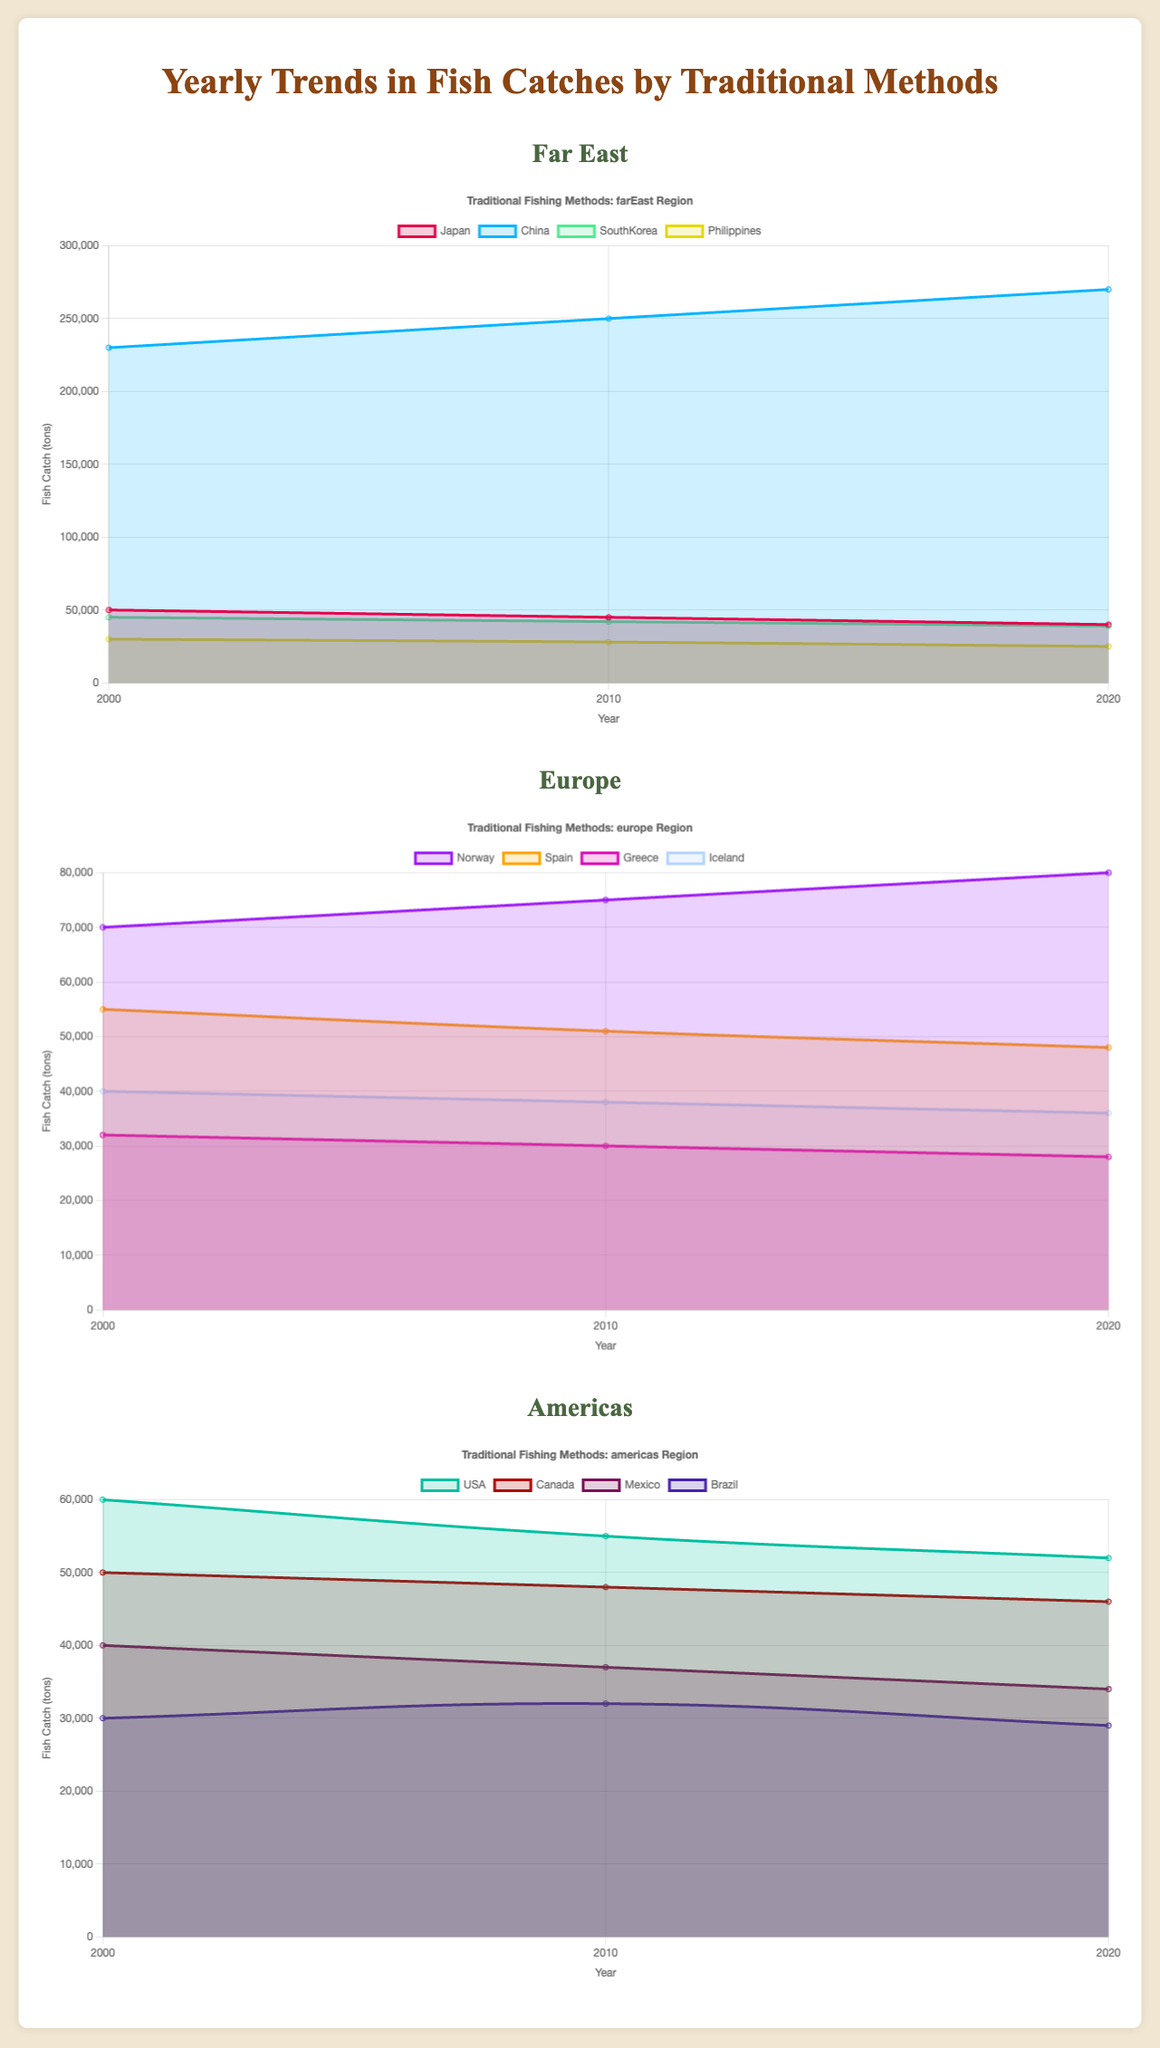What is the trend of fish catches in Japan from 2000 to 2020? Looking at the Far East chart, we see that Japan’s fish catches decrease from 50000 tons in 2000 to 45000 tons in 2010, and further to 40000 tons in 2020.
Answer: Decreasing Which country in the Far East shows the highest fish catch in all years? Referring to the Far East chart, China consistently has the highest fish catches from 2000 to 2020, surpassing other countries like Japan, South Korea, and the Philippines.
Answer: China How much more fish did Norway catch compared to Greece in 2010? In the Europe chart, Norway caught 75000 tons in 2010, while Greece caught 30000 tons. The difference is 75000 - 30000 = 45000 tons.
Answer: 45000 tons What is the average fish catch of Canada in the years 2000, 2010, and 2020? In the Americas chart, Canada’s fish catches are 50000 tons in 2000, 48000 tons in 2010, and 46000 tons in 2020. The average is calculated as (50000 + 48000 + 46000) / 3 = 48000 tons.
Answer: 48000 tons Which European country experienced a decline in fish catches from 2000 to 2020? In the Europe chart, Spain’s fish catches decreased from 55000 tons in 2000 to 51000 tons in 2010, and further to 48000 tons in 2020.
Answer: Spain Between the USA and Mexico, which country had a steeper decline in fish catches from 2000 to 2020? In the Americas chart, the USA’s fish catches decreased from 60000 tons in 2000 to 52000 tons in 2020, a difference of 8000 tons. Mexico’s catches decreased from 40000 tons in 2000 to 34000 tons in 2020, a difference of 6000 tons. Therefore, the USA had a steeper decline.
Answer: USA What is the total fish catch for South Korea over the three recorded years? South Korea’s fish catches in the Far East chart are 45000 tons in 2000, 42000 tons in 2010, and 39000 tons in 2020. The total is 45000 + 42000 + 39000 = 126000 tons.
Answer: 126000 tons Which two countries show an increasing trend in fish catches from 2000 to 2020? In the Europe chart, Norway’s catches increase from 70000 tons in 2000 to 80000 tons in 2020. In the Far East chart, China’s catches increase from 230000 tons in 2000 to 270000 tons in 2020. Both Norway and China show an increasing trend.
Answer: Norway and China 